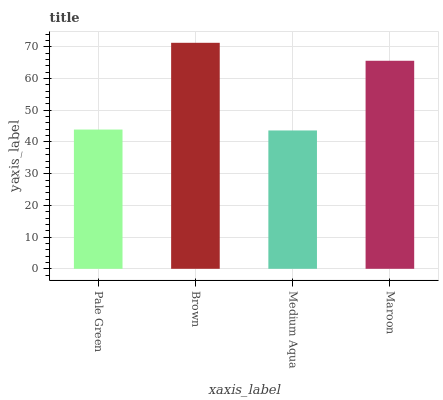Is Medium Aqua the minimum?
Answer yes or no. Yes. Is Brown the maximum?
Answer yes or no. Yes. Is Brown the minimum?
Answer yes or no. No. Is Medium Aqua the maximum?
Answer yes or no. No. Is Brown greater than Medium Aqua?
Answer yes or no. Yes. Is Medium Aqua less than Brown?
Answer yes or no. Yes. Is Medium Aqua greater than Brown?
Answer yes or no. No. Is Brown less than Medium Aqua?
Answer yes or no. No. Is Maroon the high median?
Answer yes or no. Yes. Is Pale Green the low median?
Answer yes or no. Yes. Is Medium Aqua the high median?
Answer yes or no. No. Is Medium Aqua the low median?
Answer yes or no. No. 